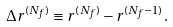<formula> <loc_0><loc_0><loc_500><loc_500>\Delta r ^ { ( N _ { f } ) } \equiv r ^ { ( N _ { f } ) } - r ^ { ( N _ { f } - 1 ) } .</formula> 